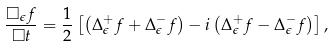Convert formula to latex. <formula><loc_0><loc_0><loc_500><loc_500>\frac { \square _ { \epsilon } f } { \square t } = \frac { 1 } { 2 } \left [ \left ( \Delta _ { \epsilon } ^ { + } f + \Delta _ { \epsilon } ^ { - } f \right ) - i \left ( \Delta _ { \epsilon } ^ { + } f - \Delta _ { \epsilon } ^ { - } f \right ) \right ] ,</formula> 